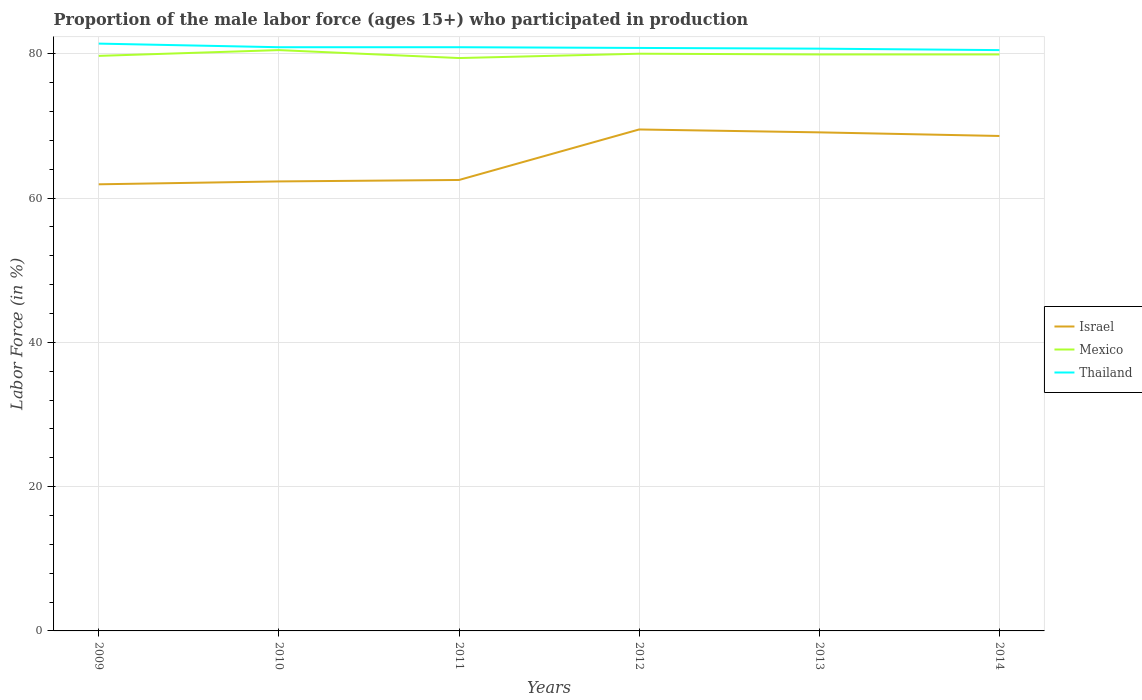Does the line corresponding to Mexico intersect with the line corresponding to Thailand?
Your response must be concise. No. Across all years, what is the maximum proportion of the male labor force who participated in production in Thailand?
Ensure brevity in your answer.  80.5. In which year was the proportion of the male labor force who participated in production in Israel maximum?
Your answer should be compact. 2009. What is the total proportion of the male labor force who participated in production in Israel in the graph?
Your answer should be very brief. -0.6. What is the difference between the highest and the second highest proportion of the male labor force who participated in production in Israel?
Ensure brevity in your answer.  7.6. Is the proportion of the male labor force who participated in production in Mexico strictly greater than the proportion of the male labor force who participated in production in Israel over the years?
Give a very brief answer. No. Are the values on the major ticks of Y-axis written in scientific E-notation?
Give a very brief answer. No. Where does the legend appear in the graph?
Provide a succinct answer. Center right. How many legend labels are there?
Your answer should be very brief. 3. What is the title of the graph?
Provide a succinct answer. Proportion of the male labor force (ages 15+) who participated in production. Does "Croatia" appear as one of the legend labels in the graph?
Give a very brief answer. No. What is the label or title of the Y-axis?
Offer a terse response. Labor Force (in %). What is the Labor Force (in %) in Israel in 2009?
Provide a short and direct response. 61.9. What is the Labor Force (in %) of Mexico in 2009?
Your answer should be compact. 79.7. What is the Labor Force (in %) of Thailand in 2009?
Your answer should be compact. 81.4. What is the Labor Force (in %) in Israel in 2010?
Offer a terse response. 62.3. What is the Labor Force (in %) in Mexico in 2010?
Offer a very short reply. 80.5. What is the Labor Force (in %) of Thailand in 2010?
Make the answer very short. 80.9. What is the Labor Force (in %) in Israel in 2011?
Offer a terse response. 62.5. What is the Labor Force (in %) in Mexico in 2011?
Ensure brevity in your answer.  79.4. What is the Labor Force (in %) of Thailand in 2011?
Give a very brief answer. 80.9. What is the Labor Force (in %) in Israel in 2012?
Your response must be concise. 69.5. What is the Labor Force (in %) of Mexico in 2012?
Keep it short and to the point. 80. What is the Labor Force (in %) of Thailand in 2012?
Offer a very short reply. 80.8. What is the Labor Force (in %) in Israel in 2013?
Provide a succinct answer. 69.1. What is the Labor Force (in %) of Mexico in 2013?
Make the answer very short. 79.9. What is the Labor Force (in %) of Thailand in 2013?
Your answer should be very brief. 80.7. What is the Labor Force (in %) of Israel in 2014?
Make the answer very short. 68.6. What is the Labor Force (in %) of Mexico in 2014?
Provide a short and direct response. 79.9. What is the Labor Force (in %) of Thailand in 2014?
Make the answer very short. 80.5. Across all years, what is the maximum Labor Force (in %) in Israel?
Provide a succinct answer. 69.5. Across all years, what is the maximum Labor Force (in %) in Mexico?
Make the answer very short. 80.5. Across all years, what is the maximum Labor Force (in %) in Thailand?
Your answer should be compact. 81.4. Across all years, what is the minimum Labor Force (in %) of Israel?
Ensure brevity in your answer.  61.9. Across all years, what is the minimum Labor Force (in %) of Mexico?
Your answer should be compact. 79.4. Across all years, what is the minimum Labor Force (in %) in Thailand?
Offer a very short reply. 80.5. What is the total Labor Force (in %) in Israel in the graph?
Offer a terse response. 393.9. What is the total Labor Force (in %) of Mexico in the graph?
Your response must be concise. 479.4. What is the total Labor Force (in %) of Thailand in the graph?
Your response must be concise. 485.2. What is the difference between the Labor Force (in %) in Israel in 2009 and that in 2010?
Offer a very short reply. -0.4. What is the difference between the Labor Force (in %) in Mexico in 2009 and that in 2010?
Give a very brief answer. -0.8. What is the difference between the Labor Force (in %) in Thailand in 2009 and that in 2010?
Keep it short and to the point. 0.5. What is the difference between the Labor Force (in %) of Mexico in 2009 and that in 2011?
Your response must be concise. 0.3. What is the difference between the Labor Force (in %) of Israel in 2009 and that in 2012?
Provide a succinct answer. -7.6. What is the difference between the Labor Force (in %) of Israel in 2009 and that in 2013?
Offer a very short reply. -7.2. What is the difference between the Labor Force (in %) in Mexico in 2009 and that in 2013?
Your answer should be compact. -0.2. What is the difference between the Labor Force (in %) in Thailand in 2009 and that in 2013?
Offer a terse response. 0.7. What is the difference between the Labor Force (in %) in Mexico in 2009 and that in 2014?
Offer a very short reply. -0.2. What is the difference between the Labor Force (in %) in Thailand in 2010 and that in 2011?
Ensure brevity in your answer.  0. What is the difference between the Labor Force (in %) in Israel in 2010 and that in 2012?
Offer a very short reply. -7.2. What is the difference between the Labor Force (in %) of Thailand in 2010 and that in 2012?
Your response must be concise. 0.1. What is the difference between the Labor Force (in %) in Mexico in 2010 and that in 2013?
Your answer should be compact. 0.6. What is the difference between the Labor Force (in %) in Thailand in 2010 and that in 2014?
Make the answer very short. 0.4. What is the difference between the Labor Force (in %) of Israel in 2011 and that in 2012?
Your response must be concise. -7. What is the difference between the Labor Force (in %) in Mexico in 2011 and that in 2012?
Give a very brief answer. -0.6. What is the difference between the Labor Force (in %) in Thailand in 2011 and that in 2012?
Give a very brief answer. 0.1. What is the difference between the Labor Force (in %) in Israel in 2011 and that in 2013?
Give a very brief answer. -6.6. What is the difference between the Labor Force (in %) in Mexico in 2011 and that in 2013?
Provide a succinct answer. -0.5. What is the difference between the Labor Force (in %) of Mexico in 2011 and that in 2014?
Give a very brief answer. -0.5. What is the difference between the Labor Force (in %) of Thailand in 2011 and that in 2014?
Offer a terse response. 0.4. What is the difference between the Labor Force (in %) in Israel in 2012 and that in 2013?
Your response must be concise. 0.4. What is the difference between the Labor Force (in %) in Mexico in 2012 and that in 2014?
Give a very brief answer. 0.1. What is the difference between the Labor Force (in %) of Thailand in 2012 and that in 2014?
Provide a short and direct response. 0.3. What is the difference between the Labor Force (in %) of Israel in 2013 and that in 2014?
Your answer should be very brief. 0.5. What is the difference between the Labor Force (in %) of Mexico in 2013 and that in 2014?
Provide a short and direct response. 0. What is the difference between the Labor Force (in %) in Thailand in 2013 and that in 2014?
Your answer should be very brief. 0.2. What is the difference between the Labor Force (in %) in Israel in 2009 and the Labor Force (in %) in Mexico in 2010?
Ensure brevity in your answer.  -18.6. What is the difference between the Labor Force (in %) of Israel in 2009 and the Labor Force (in %) of Mexico in 2011?
Your response must be concise. -17.5. What is the difference between the Labor Force (in %) of Israel in 2009 and the Labor Force (in %) of Thailand in 2011?
Make the answer very short. -19. What is the difference between the Labor Force (in %) in Israel in 2009 and the Labor Force (in %) in Mexico in 2012?
Ensure brevity in your answer.  -18.1. What is the difference between the Labor Force (in %) of Israel in 2009 and the Labor Force (in %) of Thailand in 2012?
Make the answer very short. -18.9. What is the difference between the Labor Force (in %) of Israel in 2009 and the Labor Force (in %) of Thailand in 2013?
Ensure brevity in your answer.  -18.8. What is the difference between the Labor Force (in %) of Mexico in 2009 and the Labor Force (in %) of Thailand in 2013?
Provide a short and direct response. -1. What is the difference between the Labor Force (in %) of Israel in 2009 and the Labor Force (in %) of Mexico in 2014?
Offer a terse response. -18. What is the difference between the Labor Force (in %) in Israel in 2009 and the Labor Force (in %) in Thailand in 2014?
Provide a succinct answer. -18.6. What is the difference between the Labor Force (in %) of Mexico in 2009 and the Labor Force (in %) of Thailand in 2014?
Provide a short and direct response. -0.8. What is the difference between the Labor Force (in %) in Israel in 2010 and the Labor Force (in %) in Mexico in 2011?
Your answer should be compact. -17.1. What is the difference between the Labor Force (in %) of Israel in 2010 and the Labor Force (in %) of Thailand in 2011?
Your answer should be very brief. -18.6. What is the difference between the Labor Force (in %) of Israel in 2010 and the Labor Force (in %) of Mexico in 2012?
Provide a succinct answer. -17.7. What is the difference between the Labor Force (in %) of Israel in 2010 and the Labor Force (in %) of Thailand in 2012?
Offer a terse response. -18.5. What is the difference between the Labor Force (in %) of Mexico in 2010 and the Labor Force (in %) of Thailand in 2012?
Offer a very short reply. -0.3. What is the difference between the Labor Force (in %) of Israel in 2010 and the Labor Force (in %) of Mexico in 2013?
Keep it short and to the point. -17.6. What is the difference between the Labor Force (in %) in Israel in 2010 and the Labor Force (in %) in Thailand in 2013?
Make the answer very short. -18.4. What is the difference between the Labor Force (in %) of Mexico in 2010 and the Labor Force (in %) of Thailand in 2013?
Make the answer very short. -0.2. What is the difference between the Labor Force (in %) of Israel in 2010 and the Labor Force (in %) of Mexico in 2014?
Your answer should be compact. -17.6. What is the difference between the Labor Force (in %) of Israel in 2010 and the Labor Force (in %) of Thailand in 2014?
Your answer should be very brief. -18.2. What is the difference between the Labor Force (in %) of Israel in 2011 and the Labor Force (in %) of Mexico in 2012?
Make the answer very short. -17.5. What is the difference between the Labor Force (in %) of Israel in 2011 and the Labor Force (in %) of Thailand in 2012?
Keep it short and to the point. -18.3. What is the difference between the Labor Force (in %) in Mexico in 2011 and the Labor Force (in %) in Thailand in 2012?
Give a very brief answer. -1.4. What is the difference between the Labor Force (in %) of Israel in 2011 and the Labor Force (in %) of Mexico in 2013?
Ensure brevity in your answer.  -17.4. What is the difference between the Labor Force (in %) of Israel in 2011 and the Labor Force (in %) of Thailand in 2013?
Provide a short and direct response. -18.2. What is the difference between the Labor Force (in %) of Israel in 2011 and the Labor Force (in %) of Mexico in 2014?
Your response must be concise. -17.4. What is the difference between the Labor Force (in %) in Mexico in 2011 and the Labor Force (in %) in Thailand in 2014?
Offer a very short reply. -1.1. What is the difference between the Labor Force (in %) in Israel in 2012 and the Labor Force (in %) in Thailand in 2013?
Provide a succinct answer. -11.2. What is the difference between the Labor Force (in %) of Mexico in 2012 and the Labor Force (in %) of Thailand in 2014?
Your answer should be very brief. -0.5. What is the difference between the Labor Force (in %) in Israel in 2013 and the Labor Force (in %) in Mexico in 2014?
Ensure brevity in your answer.  -10.8. What is the difference between the Labor Force (in %) in Israel in 2013 and the Labor Force (in %) in Thailand in 2014?
Make the answer very short. -11.4. What is the average Labor Force (in %) in Israel per year?
Keep it short and to the point. 65.65. What is the average Labor Force (in %) in Mexico per year?
Ensure brevity in your answer.  79.9. What is the average Labor Force (in %) in Thailand per year?
Ensure brevity in your answer.  80.87. In the year 2009, what is the difference between the Labor Force (in %) of Israel and Labor Force (in %) of Mexico?
Give a very brief answer. -17.8. In the year 2009, what is the difference between the Labor Force (in %) of Israel and Labor Force (in %) of Thailand?
Your answer should be very brief. -19.5. In the year 2010, what is the difference between the Labor Force (in %) of Israel and Labor Force (in %) of Mexico?
Ensure brevity in your answer.  -18.2. In the year 2010, what is the difference between the Labor Force (in %) in Israel and Labor Force (in %) in Thailand?
Your response must be concise. -18.6. In the year 2011, what is the difference between the Labor Force (in %) in Israel and Labor Force (in %) in Mexico?
Make the answer very short. -16.9. In the year 2011, what is the difference between the Labor Force (in %) in Israel and Labor Force (in %) in Thailand?
Give a very brief answer. -18.4. In the year 2011, what is the difference between the Labor Force (in %) of Mexico and Labor Force (in %) of Thailand?
Offer a very short reply. -1.5. In the year 2012, what is the difference between the Labor Force (in %) in Israel and Labor Force (in %) in Mexico?
Offer a terse response. -10.5. In the year 2013, what is the difference between the Labor Force (in %) in Israel and Labor Force (in %) in Thailand?
Give a very brief answer. -11.6. What is the ratio of the Labor Force (in %) of Mexico in 2009 to that in 2010?
Keep it short and to the point. 0.99. What is the ratio of the Labor Force (in %) in Thailand in 2009 to that in 2010?
Offer a terse response. 1.01. What is the ratio of the Labor Force (in %) in Mexico in 2009 to that in 2011?
Ensure brevity in your answer.  1. What is the ratio of the Labor Force (in %) of Israel in 2009 to that in 2012?
Your answer should be compact. 0.89. What is the ratio of the Labor Force (in %) in Mexico in 2009 to that in 2012?
Ensure brevity in your answer.  1. What is the ratio of the Labor Force (in %) in Thailand in 2009 to that in 2012?
Offer a very short reply. 1.01. What is the ratio of the Labor Force (in %) in Israel in 2009 to that in 2013?
Offer a very short reply. 0.9. What is the ratio of the Labor Force (in %) in Thailand in 2009 to that in 2013?
Provide a succinct answer. 1.01. What is the ratio of the Labor Force (in %) of Israel in 2009 to that in 2014?
Give a very brief answer. 0.9. What is the ratio of the Labor Force (in %) in Thailand in 2009 to that in 2014?
Your answer should be very brief. 1.01. What is the ratio of the Labor Force (in %) in Israel in 2010 to that in 2011?
Your response must be concise. 1. What is the ratio of the Labor Force (in %) of Mexico in 2010 to that in 2011?
Give a very brief answer. 1.01. What is the ratio of the Labor Force (in %) in Thailand in 2010 to that in 2011?
Offer a terse response. 1. What is the ratio of the Labor Force (in %) in Israel in 2010 to that in 2012?
Provide a succinct answer. 0.9. What is the ratio of the Labor Force (in %) in Mexico in 2010 to that in 2012?
Provide a short and direct response. 1.01. What is the ratio of the Labor Force (in %) in Israel in 2010 to that in 2013?
Ensure brevity in your answer.  0.9. What is the ratio of the Labor Force (in %) in Mexico in 2010 to that in 2013?
Make the answer very short. 1.01. What is the ratio of the Labor Force (in %) of Israel in 2010 to that in 2014?
Offer a very short reply. 0.91. What is the ratio of the Labor Force (in %) in Mexico in 2010 to that in 2014?
Keep it short and to the point. 1.01. What is the ratio of the Labor Force (in %) of Israel in 2011 to that in 2012?
Offer a terse response. 0.9. What is the ratio of the Labor Force (in %) of Mexico in 2011 to that in 2012?
Give a very brief answer. 0.99. What is the ratio of the Labor Force (in %) of Thailand in 2011 to that in 2012?
Make the answer very short. 1. What is the ratio of the Labor Force (in %) in Israel in 2011 to that in 2013?
Provide a short and direct response. 0.9. What is the ratio of the Labor Force (in %) of Israel in 2011 to that in 2014?
Provide a short and direct response. 0.91. What is the ratio of the Labor Force (in %) of Thailand in 2011 to that in 2014?
Give a very brief answer. 1. What is the ratio of the Labor Force (in %) of Israel in 2012 to that in 2014?
Provide a succinct answer. 1.01. What is the ratio of the Labor Force (in %) of Thailand in 2012 to that in 2014?
Keep it short and to the point. 1. What is the ratio of the Labor Force (in %) of Israel in 2013 to that in 2014?
Your answer should be compact. 1.01. What is the difference between the highest and the second highest Labor Force (in %) of Israel?
Your response must be concise. 0.4. What is the difference between the highest and the second highest Labor Force (in %) of Mexico?
Your answer should be compact. 0.5. What is the difference between the highest and the second highest Labor Force (in %) of Thailand?
Give a very brief answer. 0.5. What is the difference between the highest and the lowest Labor Force (in %) of Israel?
Offer a terse response. 7.6. What is the difference between the highest and the lowest Labor Force (in %) in Mexico?
Offer a terse response. 1.1. 